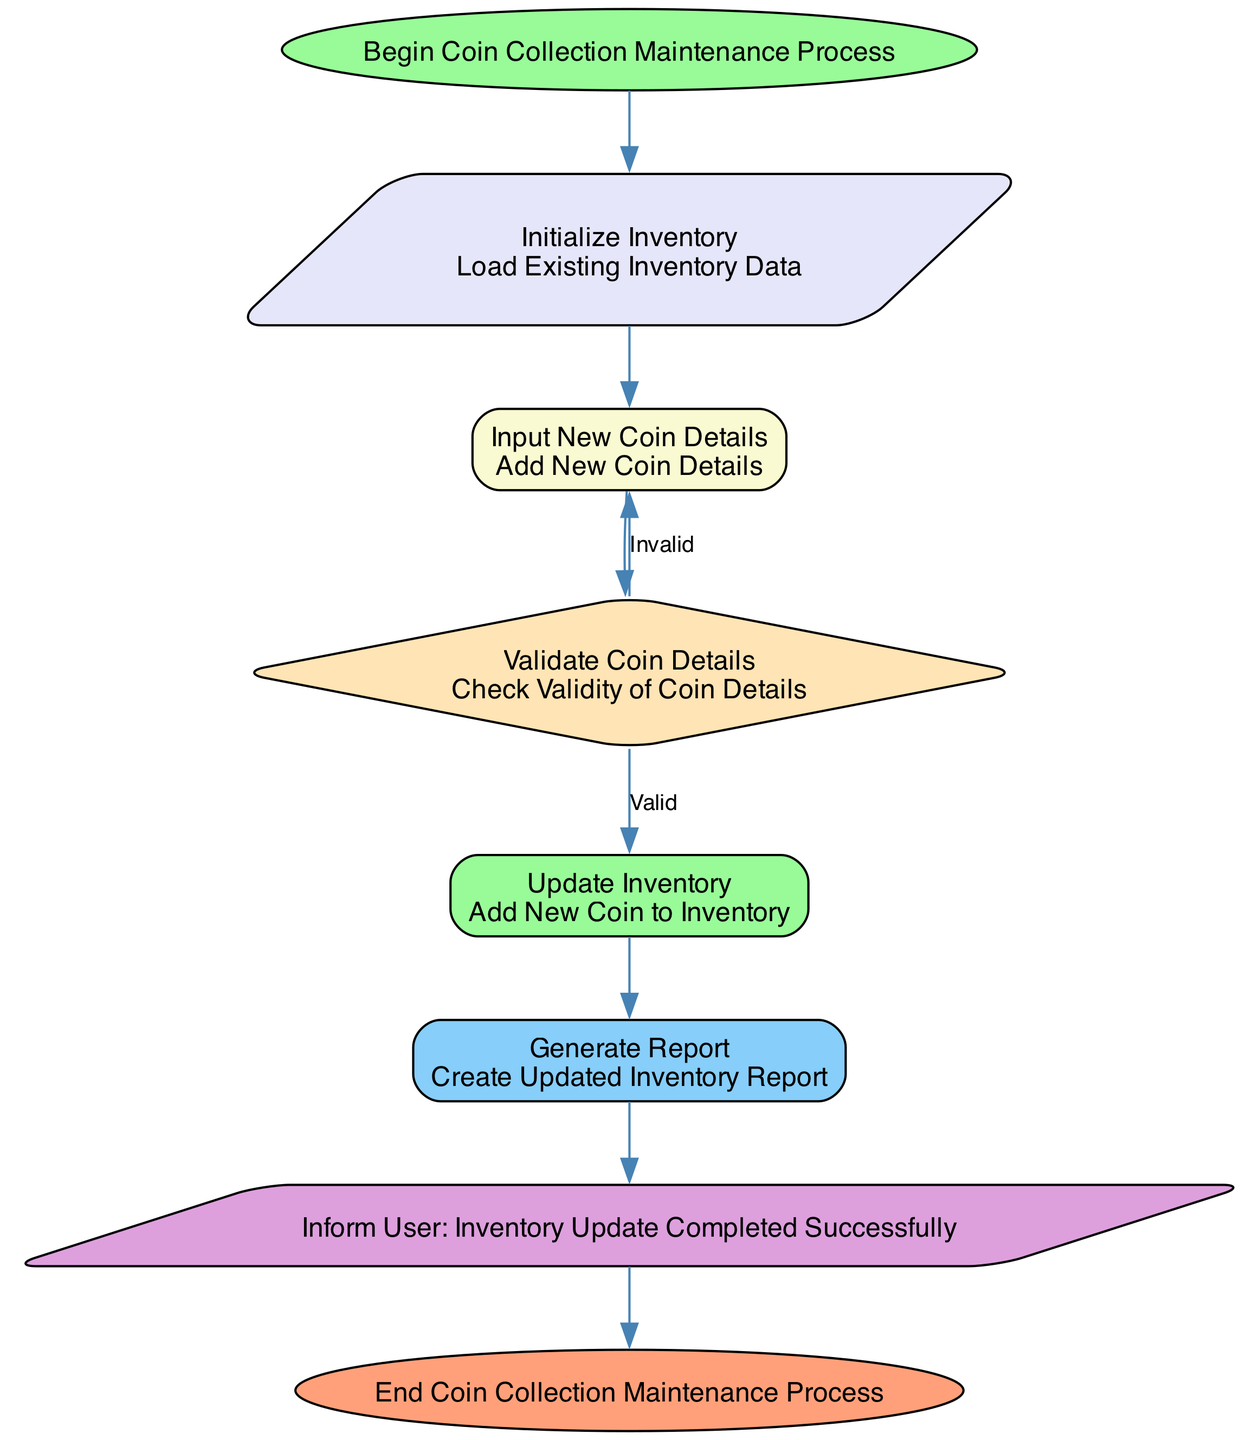What is the first node in the flowchart? The first node in the flowchart is labeled "Start", which indicates the beginning of the Coin Collection Maintenance Process.
Answer: Start How many decision nodes are there in the diagram? There is one decision node, which is "Validate Coin Details." This node evaluates whether the coin details provided are valid or invalid.
Answer: One What does the "Notify User Completion" node indicate? The "Notify User Completion" node informs the user that the inventory update process has been completed successfully, signifying the end of a successful operation.
Answer: Inventory Update Completed Successfully What happens if the coin details are invalid? If the coin details are invalid, the flowchart shows that the process loops back to the "Input New Coin Details" node, prompting the user to re-enter the details.
Answer: Loop back to Input New Coin Details Which node is responsible for creating an updated inventory report? The "Generate Report" node is responsible for creating an updated inventory report after the inventory has been successfully updated.
Answer: Generate Report How does the process flow from "Validate Coin Details" if the details are valid? If the details are valid, the flow proceeds to the "Update Inventory" node to append the new coin data to the existing inventory.
Answer: Update Inventory What type of node is "Initialize Inventory"? The "Initialize Inventory" node is a parallelogram-shaped process node, indicating data operation that involves loading existing inventory data.
Answer: Parallelogram What is the final node that indicates the end of the process? The final node labeled "End" indicates the conclusion of the Coin Collection Maintenance Process, marking where the entire flowchart concludes.
Answer: End 